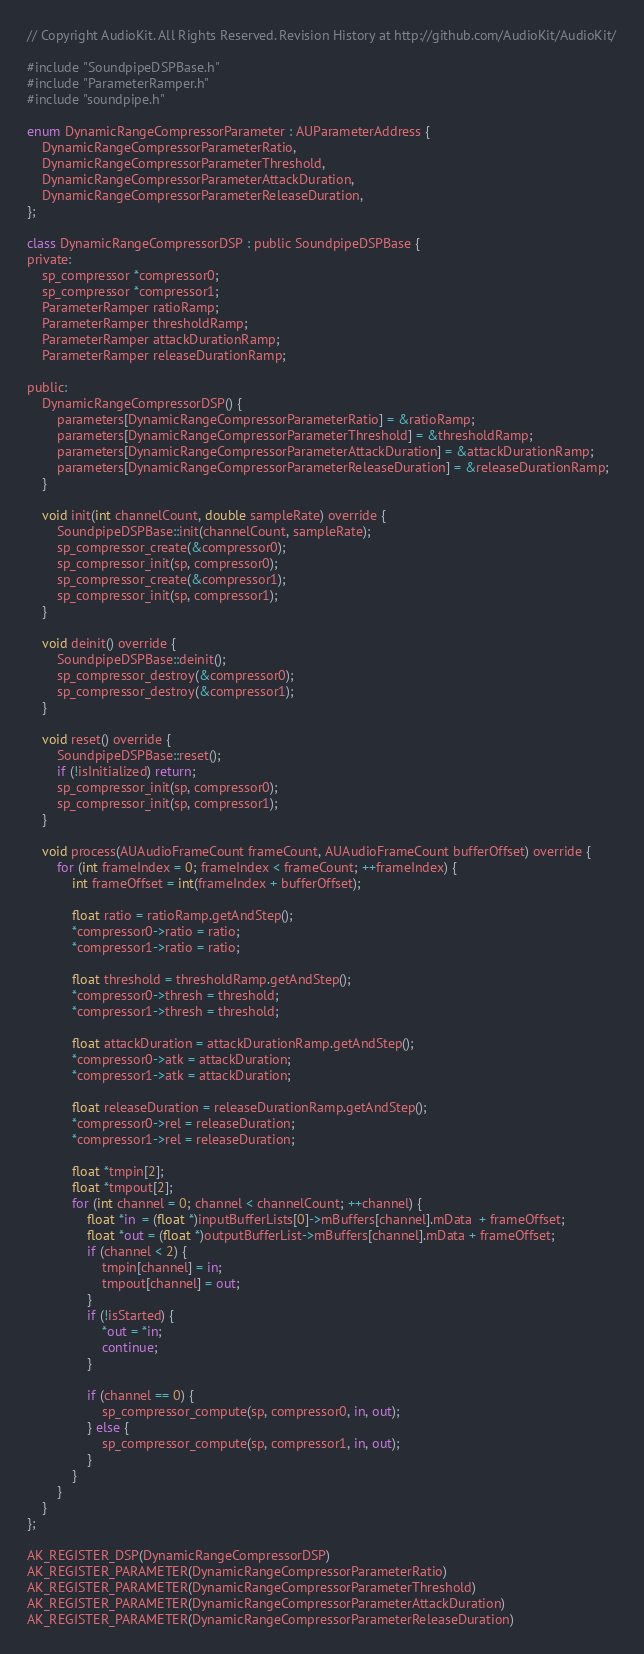<code> <loc_0><loc_0><loc_500><loc_500><_ObjectiveC_>// Copyright AudioKit. All Rights Reserved. Revision History at http://github.com/AudioKit/AudioKit/

#include "SoundpipeDSPBase.h"
#include "ParameterRamper.h"
#include "soundpipe.h"

enum DynamicRangeCompressorParameter : AUParameterAddress {
    DynamicRangeCompressorParameterRatio,
    DynamicRangeCompressorParameterThreshold,
    DynamicRangeCompressorParameterAttackDuration,
    DynamicRangeCompressorParameterReleaseDuration,
};

class DynamicRangeCompressorDSP : public SoundpipeDSPBase {
private:
    sp_compressor *compressor0;
    sp_compressor *compressor1;
    ParameterRamper ratioRamp;
    ParameterRamper thresholdRamp;
    ParameterRamper attackDurationRamp;
    ParameterRamper releaseDurationRamp;

public:
    DynamicRangeCompressorDSP() {
        parameters[DynamicRangeCompressorParameterRatio] = &ratioRamp;
        parameters[DynamicRangeCompressorParameterThreshold] = &thresholdRamp;
        parameters[DynamicRangeCompressorParameterAttackDuration] = &attackDurationRamp;
        parameters[DynamicRangeCompressorParameterReleaseDuration] = &releaseDurationRamp;
    }

    void init(int channelCount, double sampleRate) override {
        SoundpipeDSPBase::init(channelCount, sampleRate);
        sp_compressor_create(&compressor0);
        sp_compressor_init(sp, compressor0);
        sp_compressor_create(&compressor1);
        sp_compressor_init(sp, compressor1);
    }

    void deinit() override {
        SoundpipeDSPBase::deinit();
        sp_compressor_destroy(&compressor0);
        sp_compressor_destroy(&compressor1);
    }

    void reset() override {
        SoundpipeDSPBase::reset();
        if (!isInitialized) return;
        sp_compressor_init(sp, compressor0);
        sp_compressor_init(sp, compressor1);
    }

    void process(AUAudioFrameCount frameCount, AUAudioFrameCount bufferOffset) override {
        for (int frameIndex = 0; frameIndex < frameCount; ++frameIndex) {
            int frameOffset = int(frameIndex + bufferOffset);

            float ratio = ratioRamp.getAndStep();
            *compressor0->ratio = ratio;
            *compressor1->ratio = ratio;

            float threshold = thresholdRamp.getAndStep();
            *compressor0->thresh = threshold;
            *compressor1->thresh = threshold;

            float attackDuration = attackDurationRamp.getAndStep();
            *compressor0->atk = attackDuration;
            *compressor1->atk = attackDuration;

            float releaseDuration = releaseDurationRamp.getAndStep();
            *compressor0->rel = releaseDuration;
            *compressor1->rel = releaseDuration;

            float *tmpin[2];
            float *tmpout[2];
            for (int channel = 0; channel < channelCount; ++channel) {
                float *in  = (float *)inputBufferLists[0]->mBuffers[channel].mData  + frameOffset;
                float *out = (float *)outputBufferList->mBuffers[channel].mData + frameOffset;
                if (channel < 2) {
                    tmpin[channel] = in;
                    tmpout[channel] = out;
                }
                if (!isStarted) {
                    *out = *in;
                    continue;
                }

                if (channel == 0) {
                    sp_compressor_compute(sp, compressor0, in, out);
                } else {
                    sp_compressor_compute(sp, compressor1, in, out);
                }
            }
        }
    }
};

AK_REGISTER_DSP(DynamicRangeCompressorDSP)
AK_REGISTER_PARAMETER(DynamicRangeCompressorParameterRatio)
AK_REGISTER_PARAMETER(DynamicRangeCompressorParameterThreshold)
AK_REGISTER_PARAMETER(DynamicRangeCompressorParameterAttackDuration)
AK_REGISTER_PARAMETER(DynamicRangeCompressorParameterReleaseDuration)
</code> 